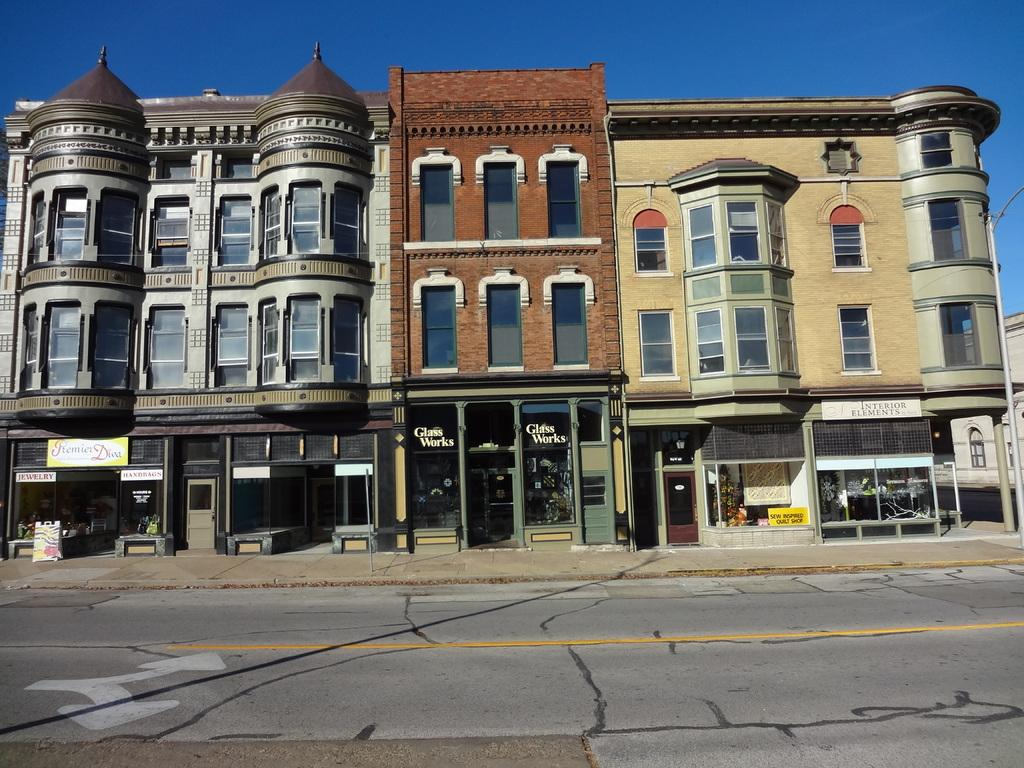What is in the foreground of the image? There is a road in the foreground of the image. What can be seen in the background of the image? There are buildings, roads, banners, and the sky visible in the background of the image. Can you describe the roads in the background? There are roads in the background of the image, but their specific characteristics are not mentioned in the facts. What is the color of the sky in the image? The color of the sky is not mentioned in the facts, so it cannot be determined from the image. What type of coast can be seen in the image? There is no coast present in the image; it features a road in the foreground and buildings, roads, banners, and the sky in the background. 